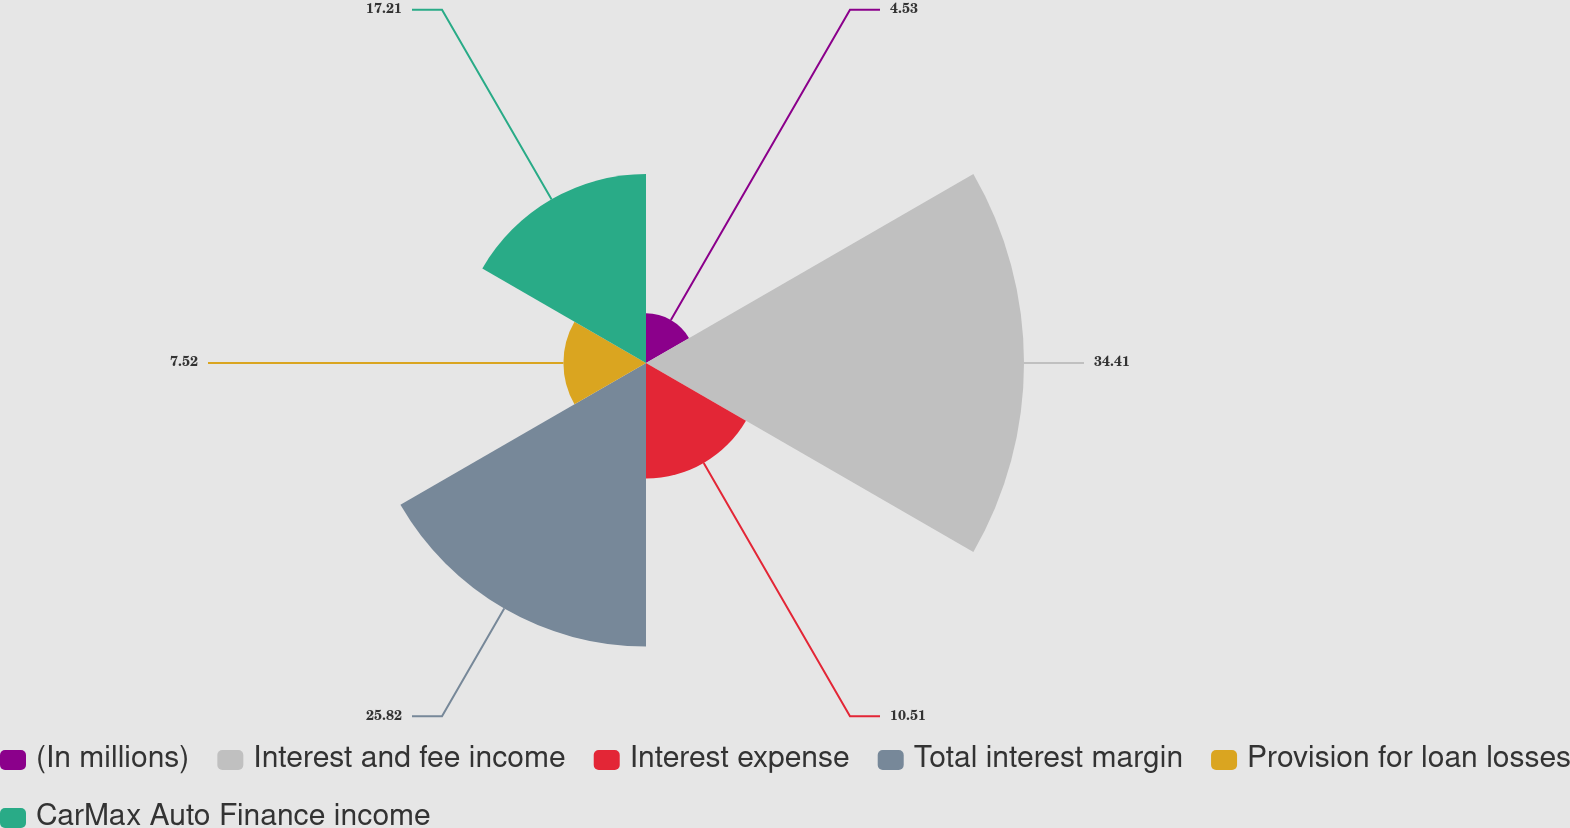Convert chart. <chart><loc_0><loc_0><loc_500><loc_500><pie_chart><fcel>(In millions)<fcel>Interest and fee income<fcel>Interest expense<fcel>Total interest margin<fcel>Provision for loan losses<fcel>CarMax Auto Finance income<nl><fcel>4.53%<fcel>34.42%<fcel>10.51%<fcel>25.82%<fcel>7.52%<fcel>17.21%<nl></chart> 